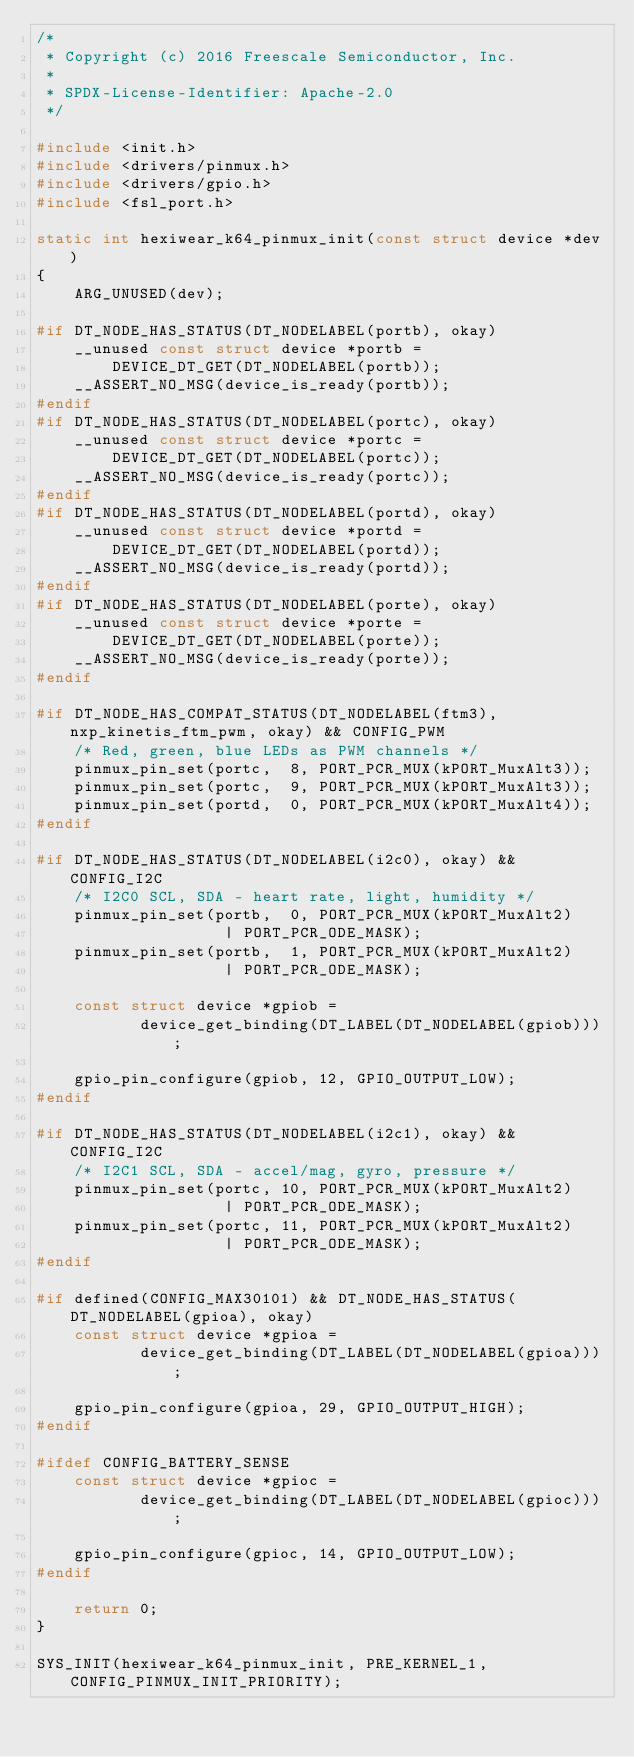<code> <loc_0><loc_0><loc_500><loc_500><_C_>/*
 * Copyright (c) 2016 Freescale Semiconductor, Inc.
 *
 * SPDX-License-Identifier: Apache-2.0
 */

#include <init.h>
#include <drivers/pinmux.h>
#include <drivers/gpio.h>
#include <fsl_port.h>

static int hexiwear_k64_pinmux_init(const struct device *dev)
{
	ARG_UNUSED(dev);

#if DT_NODE_HAS_STATUS(DT_NODELABEL(portb), okay)
	__unused const struct device *portb =
		DEVICE_DT_GET(DT_NODELABEL(portb));
	__ASSERT_NO_MSG(device_is_ready(portb));
#endif
#if DT_NODE_HAS_STATUS(DT_NODELABEL(portc), okay)
	__unused const struct device *portc =
		DEVICE_DT_GET(DT_NODELABEL(portc));
	__ASSERT_NO_MSG(device_is_ready(portc));
#endif
#if DT_NODE_HAS_STATUS(DT_NODELABEL(portd), okay)
	__unused const struct device *portd =
		DEVICE_DT_GET(DT_NODELABEL(portd));
	__ASSERT_NO_MSG(device_is_ready(portd));
#endif
#if DT_NODE_HAS_STATUS(DT_NODELABEL(porte), okay)
	__unused const struct device *porte =
		DEVICE_DT_GET(DT_NODELABEL(porte));
	__ASSERT_NO_MSG(device_is_ready(porte));
#endif

#if DT_NODE_HAS_COMPAT_STATUS(DT_NODELABEL(ftm3), nxp_kinetis_ftm_pwm, okay) && CONFIG_PWM
	/* Red, green, blue LEDs as PWM channels */
	pinmux_pin_set(portc,  8, PORT_PCR_MUX(kPORT_MuxAlt3));
	pinmux_pin_set(portc,  9, PORT_PCR_MUX(kPORT_MuxAlt3));
	pinmux_pin_set(portd,  0, PORT_PCR_MUX(kPORT_MuxAlt4));
#endif

#if DT_NODE_HAS_STATUS(DT_NODELABEL(i2c0), okay) && CONFIG_I2C
	/* I2C0 SCL, SDA - heart rate, light, humidity */
	pinmux_pin_set(portb,  0, PORT_PCR_MUX(kPORT_MuxAlt2)
					| PORT_PCR_ODE_MASK);
	pinmux_pin_set(portb,  1, PORT_PCR_MUX(kPORT_MuxAlt2)
					| PORT_PCR_ODE_MASK);

	const struct device *gpiob =
	       device_get_binding(DT_LABEL(DT_NODELABEL(gpiob)));

	gpio_pin_configure(gpiob, 12, GPIO_OUTPUT_LOW);
#endif

#if DT_NODE_HAS_STATUS(DT_NODELABEL(i2c1), okay) && CONFIG_I2C
	/* I2C1 SCL, SDA - accel/mag, gyro, pressure */
	pinmux_pin_set(portc, 10, PORT_PCR_MUX(kPORT_MuxAlt2)
					| PORT_PCR_ODE_MASK);
	pinmux_pin_set(portc, 11, PORT_PCR_MUX(kPORT_MuxAlt2)
					| PORT_PCR_ODE_MASK);
#endif

#if defined(CONFIG_MAX30101) && DT_NODE_HAS_STATUS(DT_NODELABEL(gpioa), okay)
	const struct device *gpioa =
	       device_get_binding(DT_LABEL(DT_NODELABEL(gpioa)));

	gpio_pin_configure(gpioa, 29, GPIO_OUTPUT_HIGH);
#endif

#ifdef CONFIG_BATTERY_SENSE
	const struct device *gpioc =
	       device_get_binding(DT_LABEL(DT_NODELABEL(gpioc)));

	gpio_pin_configure(gpioc, 14, GPIO_OUTPUT_LOW);
#endif

	return 0;
}

SYS_INIT(hexiwear_k64_pinmux_init, PRE_KERNEL_1, CONFIG_PINMUX_INIT_PRIORITY);
</code> 